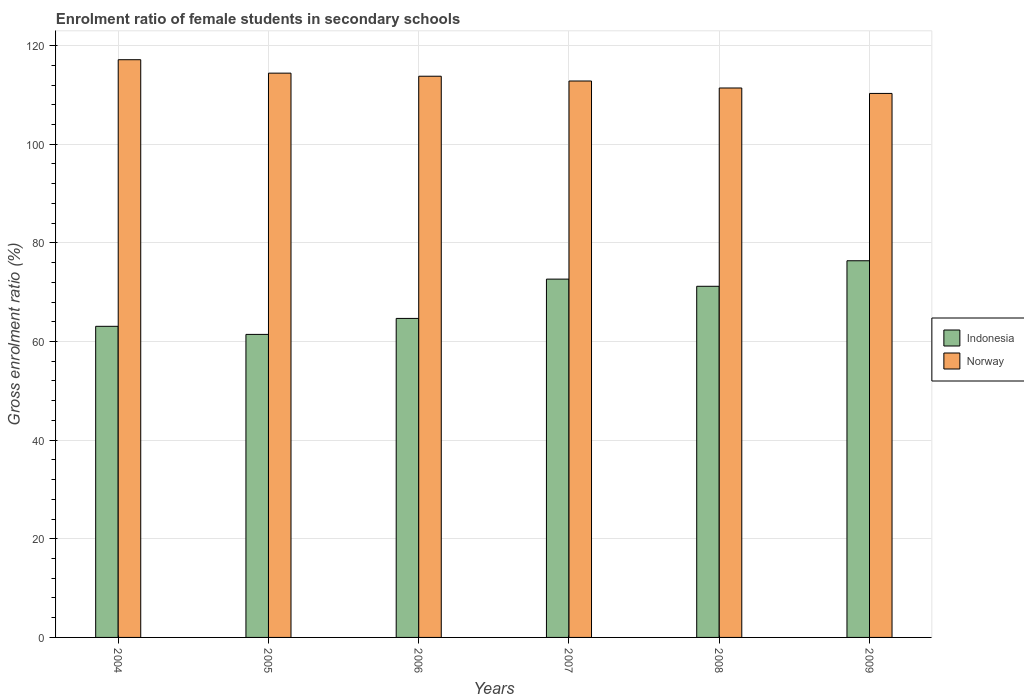How many different coloured bars are there?
Provide a succinct answer. 2. How many groups of bars are there?
Give a very brief answer. 6. Are the number of bars on each tick of the X-axis equal?
Your answer should be very brief. Yes. How many bars are there on the 5th tick from the left?
Give a very brief answer. 2. How many bars are there on the 6th tick from the right?
Make the answer very short. 2. What is the enrolment ratio of female students in secondary schools in Norway in 2005?
Keep it short and to the point. 114.42. Across all years, what is the maximum enrolment ratio of female students in secondary schools in Indonesia?
Give a very brief answer. 76.38. Across all years, what is the minimum enrolment ratio of female students in secondary schools in Norway?
Make the answer very short. 110.31. In which year was the enrolment ratio of female students in secondary schools in Norway maximum?
Your answer should be very brief. 2004. In which year was the enrolment ratio of female students in secondary schools in Norway minimum?
Ensure brevity in your answer.  2009. What is the total enrolment ratio of female students in secondary schools in Indonesia in the graph?
Give a very brief answer. 409.46. What is the difference between the enrolment ratio of female students in secondary schools in Norway in 2006 and that in 2009?
Your answer should be very brief. 3.49. What is the difference between the enrolment ratio of female students in secondary schools in Indonesia in 2009 and the enrolment ratio of female students in secondary schools in Norway in 2004?
Your answer should be compact. -40.77. What is the average enrolment ratio of female students in secondary schools in Norway per year?
Your answer should be very brief. 113.32. In the year 2007, what is the difference between the enrolment ratio of female students in secondary schools in Norway and enrolment ratio of female students in secondary schools in Indonesia?
Offer a very short reply. 40.17. What is the ratio of the enrolment ratio of female students in secondary schools in Indonesia in 2004 to that in 2009?
Keep it short and to the point. 0.83. Is the enrolment ratio of female students in secondary schools in Norway in 2007 less than that in 2009?
Make the answer very short. No. Is the difference between the enrolment ratio of female students in secondary schools in Norway in 2006 and 2008 greater than the difference between the enrolment ratio of female students in secondary schools in Indonesia in 2006 and 2008?
Provide a short and direct response. Yes. What is the difference between the highest and the second highest enrolment ratio of female students in secondary schools in Norway?
Your answer should be very brief. 2.73. What is the difference between the highest and the lowest enrolment ratio of female students in secondary schools in Indonesia?
Ensure brevity in your answer.  14.93. How many years are there in the graph?
Ensure brevity in your answer.  6. Where does the legend appear in the graph?
Your answer should be very brief. Center right. What is the title of the graph?
Your answer should be compact. Enrolment ratio of female students in secondary schools. Does "Arab World" appear as one of the legend labels in the graph?
Offer a terse response. No. What is the label or title of the X-axis?
Keep it short and to the point. Years. What is the Gross enrolment ratio (%) in Indonesia in 2004?
Your answer should be compact. 63.08. What is the Gross enrolment ratio (%) in Norway in 2004?
Your response must be concise. 117.15. What is the Gross enrolment ratio (%) of Indonesia in 2005?
Your answer should be compact. 61.45. What is the Gross enrolment ratio (%) in Norway in 2005?
Your answer should be very brief. 114.42. What is the Gross enrolment ratio (%) in Indonesia in 2006?
Make the answer very short. 64.69. What is the Gross enrolment ratio (%) in Norway in 2006?
Your response must be concise. 113.8. What is the Gross enrolment ratio (%) of Indonesia in 2007?
Ensure brevity in your answer.  72.66. What is the Gross enrolment ratio (%) in Norway in 2007?
Your answer should be very brief. 112.83. What is the Gross enrolment ratio (%) of Indonesia in 2008?
Provide a short and direct response. 71.2. What is the Gross enrolment ratio (%) in Norway in 2008?
Give a very brief answer. 111.41. What is the Gross enrolment ratio (%) of Indonesia in 2009?
Make the answer very short. 76.38. What is the Gross enrolment ratio (%) of Norway in 2009?
Provide a short and direct response. 110.31. Across all years, what is the maximum Gross enrolment ratio (%) in Indonesia?
Your answer should be very brief. 76.38. Across all years, what is the maximum Gross enrolment ratio (%) of Norway?
Offer a terse response. 117.15. Across all years, what is the minimum Gross enrolment ratio (%) of Indonesia?
Give a very brief answer. 61.45. Across all years, what is the minimum Gross enrolment ratio (%) of Norway?
Ensure brevity in your answer.  110.31. What is the total Gross enrolment ratio (%) in Indonesia in the graph?
Provide a short and direct response. 409.46. What is the total Gross enrolment ratio (%) in Norway in the graph?
Provide a short and direct response. 679.91. What is the difference between the Gross enrolment ratio (%) of Indonesia in 2004 and that in 2005?
Your answer should be very brief. 1.64. What is the difference between the Gross enrolment ratio (%) of Norway in 2004 and that in 2005?
Give a very brief answer. 2.73. What is the difference between the Gross enrolment ratio (%) in Indonesia in 2004 and that in 2006?
Offer a very short reply. -1.6. What is the difference between the Gross enrolment ratio (%) in Norway in 2004 and that in 2006?
Your answer should be compact. 3.35. What is the difference between the Gross enrolment ratio (%) in Indonesia in 2004 and that in 2007?
Provide a short and direct response. -9.57. What is the difference between the Gross enrolment ratio (%) in Norway in 2004 and that in 2007?
Ensure brevity in your answer.  4.32. What is the difference between the Gross enrolment ratio (%) in Indonesia in 2004 and that in 2008?
Offer a terse response. -8.12. What is the difference between the Gross enrolment ratio (%) of Norway in 2004 and that in 2008?
Ensure brevity in your answer.  5.74. What is the difference between the Gross enrolment ratio (%) of Indonesia in 2004 and that in 2009?
Ensure brevity in your answer.  -13.3. What is the difference between the Gross enrolment ratio (%) in Norway in 2004 and that in 2009?
Make the answer very short. 6.84. What is the difference between the Gross enrolment ratio (%) of Indonesia in 2005 and that in 2006?
Offer a very short reply. -3.24. What is the difference between the Gross enrolment ratio (%) in Norway in 2005 and that in 2006?
Your response must be concise. 0.62. What is the difference between the Gross enrolment ratio (%) of Indonesia in 2005 and that in 2007?
Offer a terse response. -11.21. What is the difference between the Gross enrolment ratio (%) in Norway in 2005 and that in 2007?
Keep it short and to the point. 1.59. What is the difference between the Gross enrolment ratio (%) of Indonesia in 2005 and that in 2008?
Ensure brevity in your answer.  -9.76. What is the difference between the Gross enrolment ratio (%) of Norway in 2005 and that in 2008?
Provide a short and direct response. 3.01. What is the difference between the Gross enrolment ratio (%) of Indonesia in 2005 and that in 2009?
Your answer should be very brief. -14.93. What is the difference between the Gross enrolment ratio (%) in Norway in 2005 and that in 2009?
Your response must be concise. 4.11. What is the difference between the Gross enrolment ratio (%) of Indonesia in 2006 and that in 2007?
Make the answer very short. -7.97. What is the difference between the Gross enrolment ratio (%) of Norway in 2006 and that in 2007?
Your answer should be very brief. 0.97. What is the difference between the Gross enrolment ratio (%) of Indonesia in 2006 and that in 2008?
Offer a terse response. -6.51. What is the difference between the Gross enrolment ratio (%) in Norway in 2006 and that in 2008?
Your answer should be compact. 2.39. What is the difference between the Gross enrolment ratio (%) of Indonesia in 2006 and that in 2009?
Provide a succinct answer. -11.69. What is the difference between the Gross enrolment ratio (%) in Norway in 2006 and that in 2009?
Offer a very short reply. 3.49. What is the difference between the Gross enrolment ratio (%) in Indonesia in 2007 and that in 2008?
Make the answer very short. 1.46. What is the difference between the Gross enrolment ratio (%) in Norway in 2007 and that in 2008?
Your answer should be compact. 1.42. What is the difference between the Gross enrolment ratio (%) in Indonesia in 2007 and that in 2009?
Give a very brief answer. -3.72. What is the difference between the Gross enrolment ratio (%) of Norway in 2007 and that in 2009?
Keep it short and to the point. 2.52. What is the difference between the Gross enrolment ratio (%) in Indonesia in 2008 and that in 2009?
Keep it short and to the point. -5.18. What is the difference between the Gross enrolment ratio (%) in Norway in 2008 and that in 2009?
Offer a very short reply. 1.1. What is the difference between the Gross enrolment ratio (%) of Indonesia in 2004 and the Gross enrolment ratio (%) of Norway in 2005?
Make the answer very short. -51.34. What is the difference between the Gross enrolment ratio (%) of Indonesia in 2004 and the Gross enrolment ratio (%) of Norway in 2006?
Provide a succinct answer. -50.71. What is the difference between the Gross enrolment ratio (%) of Indonesia in 2004 and the Gross enrolment ratio (%) of Norway in 2007?
Your answer should be very brief. -49.74. What is the difference between the Gross enrolment ratio (%) of Indonesia in 2004 and the Gross enrolment ratio (%) of Norway in 2008?
Offer a terse response. -48.32. What is the difference between the Gross enrolment ratio (%) in Indonesia in 2004 and the Gross enrolment ratio (%) in Norway in 2009?
Offer a very short reply. -47.22. What is the difference between the Gross enrolment ratio (%) in Indonesia in 2005 and the Gross enrolment ratio (%) in Norway in 2006?
Your answer should be very brief. -52.35. What is the difference between the Gross enrolment ratio (%) in Indonesia in 2005 and the Gross enrolment ratio (%) in Norway in 2007?
Offer a terse response. -51.38. What is the difference between the Gross enrolment ratio (%) of Indonesia in 2005 and the Gross enrolment ratio (%) of Norway in 2008?
Your answer should be very brief. -49.96. What is the difference between the Gross enrolment ratio (%) of Indonesia in 2005 and the Gross enrolment ratio (%) of Norway in 2009?
Keep it short and to the point. -48.86. What is the difference between the Gross enrolment ratio (%) in Indonesia in 2006 and the Gross enrolment ratio (%) in Norway in 2007?
Provide a short and direct response. -48.14. What is the difference between the Gross enrolment ratio (%) in Indonesia in 2006 and the Gross enrolment ratio (%) in Norway in 2008?
Give a very brief answer. -46.72. What is the difference between the Gross enrolment ratio (%) of Indonesia in 2006 and the Gross enrolment ratio (%) of Norway in 2009?
Make the answer very short. -45.62. What is the difference between the Gross enrolment ratio (%) of Indonesia in 2007 and the Gross enrolment ratio (%) of Norway in 2008?
Provide a succinct answer. -38.75. What is the difference between the Gross enrolment ratio (%) in Indonesia in 2007 and the Gross enrolment ratio (%) in Norway in 2009?
Your response must be concise. -37.65. What is the difference between the Gross enrolment ratio (%) in Indonesia in 2008 and the Gross enrolment ratio (%) in Norway in 2009?
Make the answer very short. -39.11. What is the average Gross enrolment ratio (%) of Indonesia per year?
Offer a very short reply. 68.24. What is the average Gross enrolment ratio (%) of Norway per year?
Ensure brevity in your answer.  113.32. In the year 2004, what is the difference between the Gross enrolment ratio (%) in Indonesia and Gross enrolment ratio (%) in Norway?
Keep it short and to the point. -54.06. In the year 2005, what is the difference between the Gross enrolment ratio (%) of Indonesia and Gross enrolment ratio (%) of Norway?
Your answer should be compact. -52.98. In the year 2006, what is the difference between the Gross enrolment ratio (%) in Indonesia and Gross enrolment ratio (%) in Norway?
Ensure brevity in your answer.  -49.11. In the year 2007, what is the difference between the Gross enrolment ratio (%) in Indonesia and Gross enrolment ratio (%) in Norway?
Keep it short and to the point. -40.17. In the year 2008, what is the difference between the Gross enrolment ratio (%) in Indonesia and Gross enrolment ratio (%) in Norway?
Provide a short and direct response. -40.21. In the year 2009, what is the difference between the Gross enrolment ratio (%) in Indonesia and Gross enrolment ratio (%) in Norway?
Your answer should be compact. -33.93. What is the ratio of the Gross enrolment ratio (%) in Indonesia in 2004 to that in 2005?
Provide a succinct answer. 1.03. What is the ratio of the Gross enrolment ratio (%) in Norway in 2004 to that in 2005?
Provide a succinct answer. 1.02. What is the ratio of the Gross enrolment ratio (%) in Indonesia in 2004 to that in 2006?
Offer a very short reply. 0.98. What is the ratio of the Gross enrolment ratio (%) of Norway in 2004 to that in 2006?
Keep it short and to the point. 1.03. What is the ratio of the Gross enrolment ratio (%) of Indonesia in 2004 to that in 2007?
Give a very brief answer. 0.87. What is the ratio of the Gross enrolment ratio (%) in Norway in 2004 to that in 2007?
Your answer should be compact. 1.04. What is the ratio of the Gross enrolment ratio (%) in Indonesia in 2004 to that in 2008?
Provide a succinct answer. 0.89. What is the ratio of the Gross enrolment ratio (%) in Norway in 2004 to that in 2008?
Your answer should be compact. 1.05. What is the ratio of the Gross enrolment ratio (%) of Indonesia in 2004 to that in 2009?
Your answer should be very brief. 0.83. What is the ratio of the Gross enrolment ratio (%) in Norway in 2004 to that in 2009?
Offer a terse response. 1.06. What is the ratio of the Gross enrolment ratio (%) in Indonesia in 2005 to that in 2006?
Give a very brief answer. 0.95. What is the ratio of the Gross enrolment ratio (%) in Norway in 2005 to that in 2006?
Keep it short and to the point. 1.01. What is the ratio of the Gross enrolment ratio (%) of Indonesia in 2005 to that in 2007?
Your answer should be very brief. 0.85. What is the ratio of the Gross enrolment ratio (%) in Norway in 2005 to that in 2007?
Offer a very short reply. 1.01. What is the ratio of the Gross enrolment ratio (%) in Indonesia in 2005 to that in 2008?
Your answer should be very brief. 0.86. What is the ratio of the Gross enrolment ratio (%) in Norway in 2005 to that in 2008?
Make the answer very short. 1.03. What is the ratio of the Gross enrolment ratio (%) of Indonesia in 2005 to that in 2009?
Your answer should be compact. 0.8. What is the ratio of the Gross enrolment ratio (%) in Norway in 2005 to that in 2009?
Make the answer very short. 1.04. What is the ratio of the Gross enrolment ratio (%) of Indonesia in 2006 to that in 2007?
Ensure brevity in your answer.  0.89. What is the ratio of the Gross enrolment ratio (%) in Norway in 2006 to that in 2007?
Provide a short and direct response. 1.01. What is the ratio of the Gross enrolment ratio (%) of Indonesia in 2006 to that in 2008?
Give a very brief answer. 0.91. What is the ratio of the Gross enrolment ratio (%) in Norway in 2006 to that in 2008?
Ensure brevity in your answer.  1.02. What is the ratio of the Gross enrolment ratio (%) of Indonesia in 2006 to that in 2009?
Keep it short and to the point. 0.85. What is the ratio of the Gross enrolment ratio (%) in Norway in 2006 to that in 2009?
Your answer should be compact. 1.03. What is the ratio of the Gross enrolment ratio (%) of Indonesia in 2007 to that in 2008?
Make the answer very short. 1.02. What is the ratio of the Gross enrolment ratio (%) of Norway in 2007 to that in 2008?
Offer a terse response. 1.01. What is the ratio of the Gross enrolment ratio (%) in Indonesia in 2007 to that in 2009?
Offer a terse response. 0.95. What is the ratio of the Gross enrolment ratio (%) in Norway in 2007 to that in 2009?
Make the answer very short. 1.02. What is the ratio of the Gross enrolment ratio (%) in Indonesia in 2008 to that in 2009?
Ensure brevity in your answer.  0.93. What is the difference between the highest and the second highest Gross enrolment ratio (%) of Indonesia?
Provide a short and direct response. 3.72. What is the difference between the highest and the second highest Gross enrolment ratio (%) in Norway?
Ensure brevity in your answer.  2.73. What is the difference between the highest and the lowest Gross enrolment ratio (%) in Indonesia?
Keep it short and to the point. 14.93. What is the difference between the highest and the lowest Gross enrolment ratio (%) in Norway?
Your answer should be compact. 6.84. 